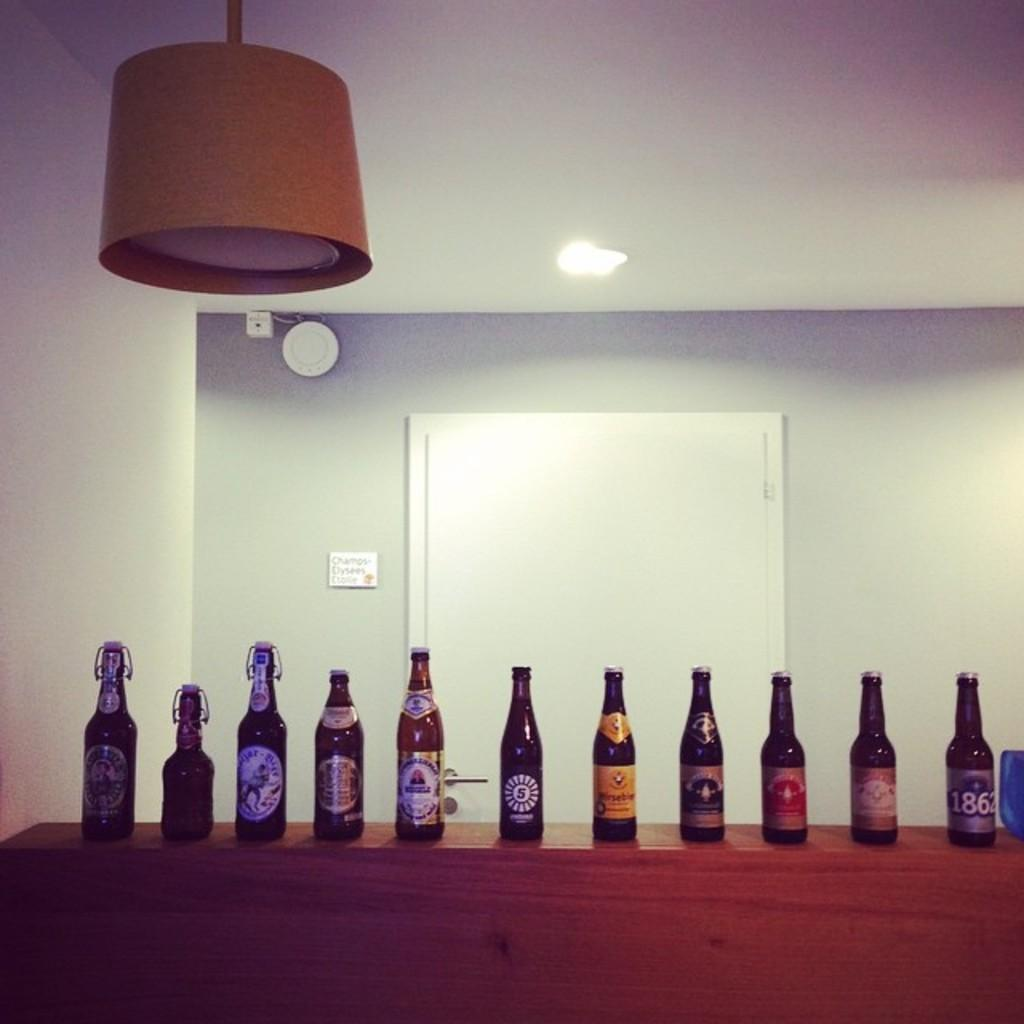What can be seen in the background of the image? There is a wall with a white door in the background. What is the source of light in the image? There is a light in the image. What objects are on the table in the image? There are bottles on a table in the image. What type of pancake is being prepared on the table in the image? There is no pancake present in the image; it only shows bottles on a table. 